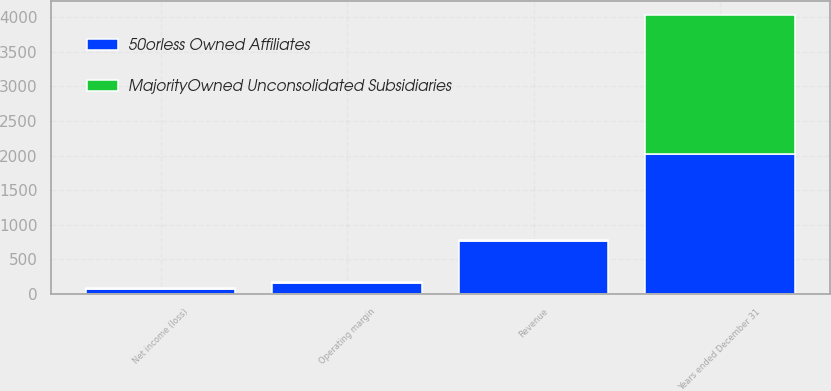Convert chart. <chart><loc_0><loc_0><loc_500><loc_500><stacked_bar_chart><ecel><fcel>Years ended December 31<fcel>Revenue<fcel>Operating margin<fcel>Net income (loss)<nl><fcel>50orless Owned Affiliates<fcel>2017<fcel>762<fcel>165<fcel>72<nl><fcel>MajorityOwned Unconsolidated Subsidiaries<fcel>2017<fcel>16<fcel>5<fcel>15<nl></chart> 